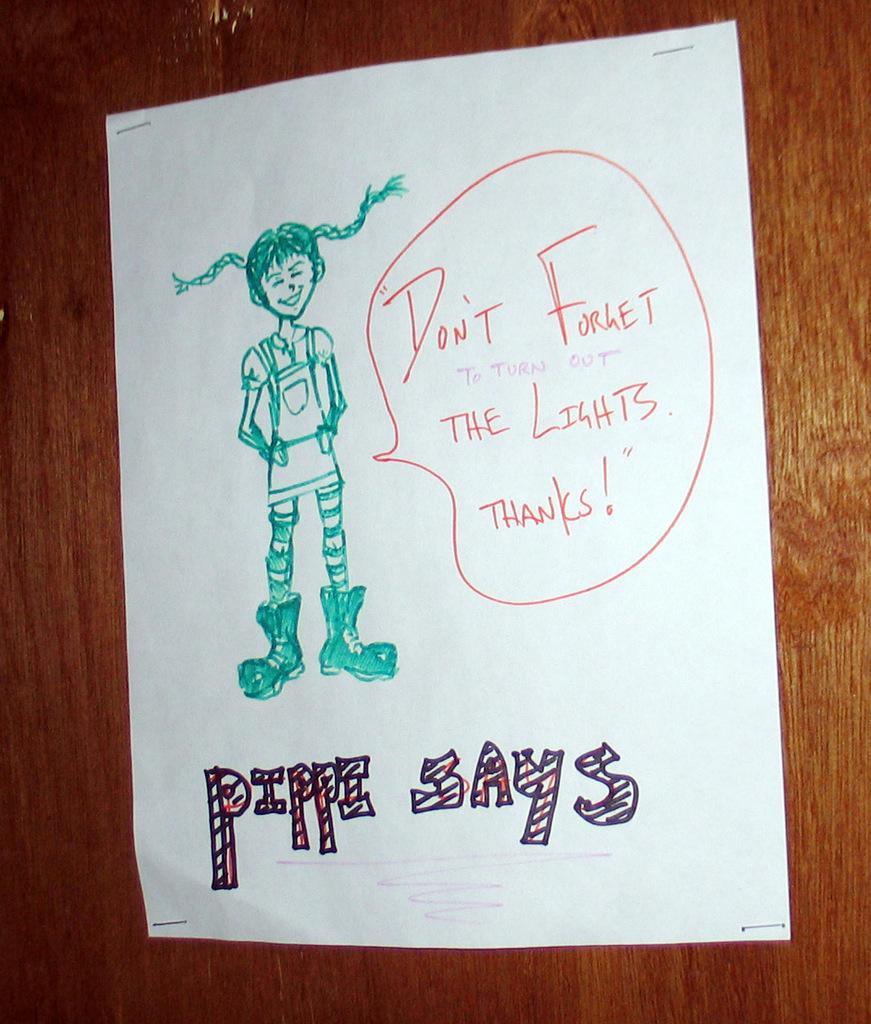Can you describe this image briefly? In this image we can see a paper. On the paper there are pictures and text. In the background of the image there is a wooden surface. 